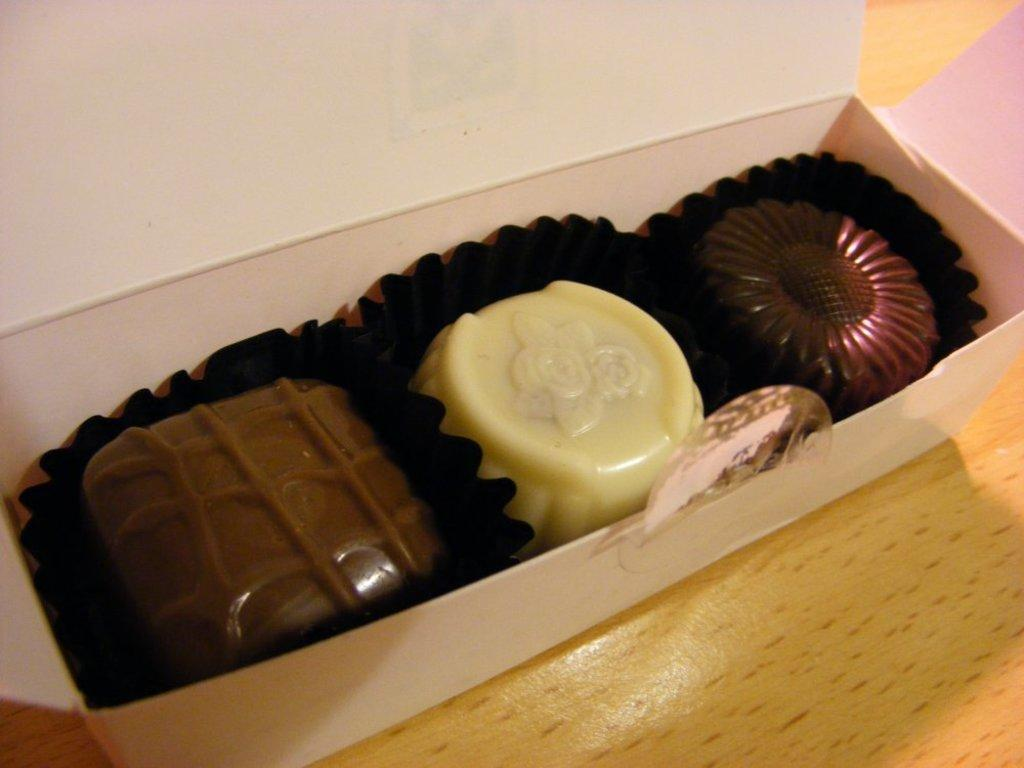What object is present in the image that is not a part of the box? The wooden plank is present in the image and is not a part of the box. What is the box placed on in the image? The box is placed on a wooden plank in the image. What is inside the box in the image? The box contains chocolates in the image. How are the chocolates arranged or presented in the box? The chocolates are on a paper in the box. What type of furniture is visible in the image? There is no furniture visible in the image; it only features a box, wooden plank, chocolates, and paper. What kind of bait is used for fishing in the image? There is no fishing or bait present in the image; it only features a box, wooden plank, chocolates, and paper. 